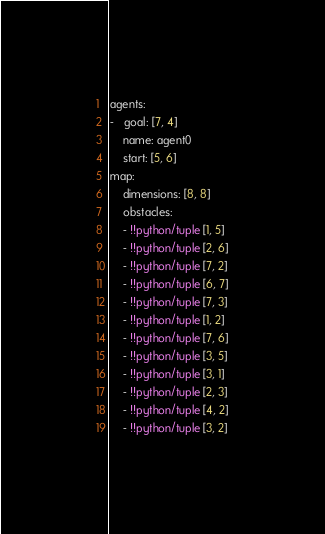Convert code to text. <code><loc_0><loc_0><loc_500><loc_500><_YAML_>agents:
-   goal: [7, 4]
    name: agent0
    start: [5, 6]
map:
    dimensions: [8, 8]
    obstacles:
    - !!python/tuple [1, 5]
    - !!python/tuple [2, 6]
    - !!python/tuple [7, 2]
    - !!python/tuple [6, 7]
    - !!python/tuple [7, 3]
    - !!python/tuple [1, 2]
    - !!python/tuple [7, 6]
    - !!python/tuple [3, 5]
    - !!python/tuple [3, 1]
    - !!python/tuple [2, 3]
    - !!python/tuple [4, 2]
    - !!python/tuple [3, 2]
</code> 